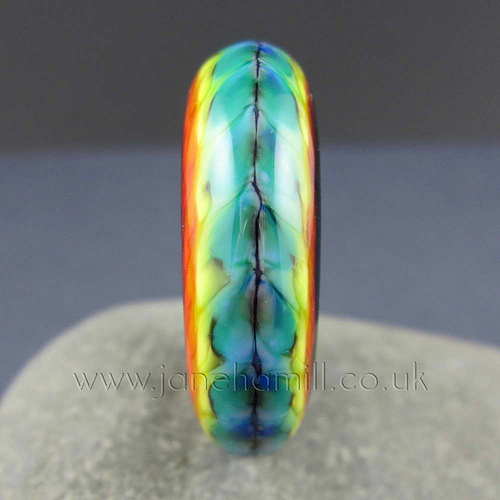<image>
Is there a asd in the wer? No. The asd is not contained within the wer. These objects have a different spatial relationship. 